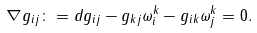<formula> <loc_0><loc_0><loc_500><loc_500>\nabla g _ { i j } \colon = d g _ { i j } - g _ { k j } \omega ^ { k } _ { i } - g _ { i k } \omega _ { j } ^ { k } = 0 .</formula> 